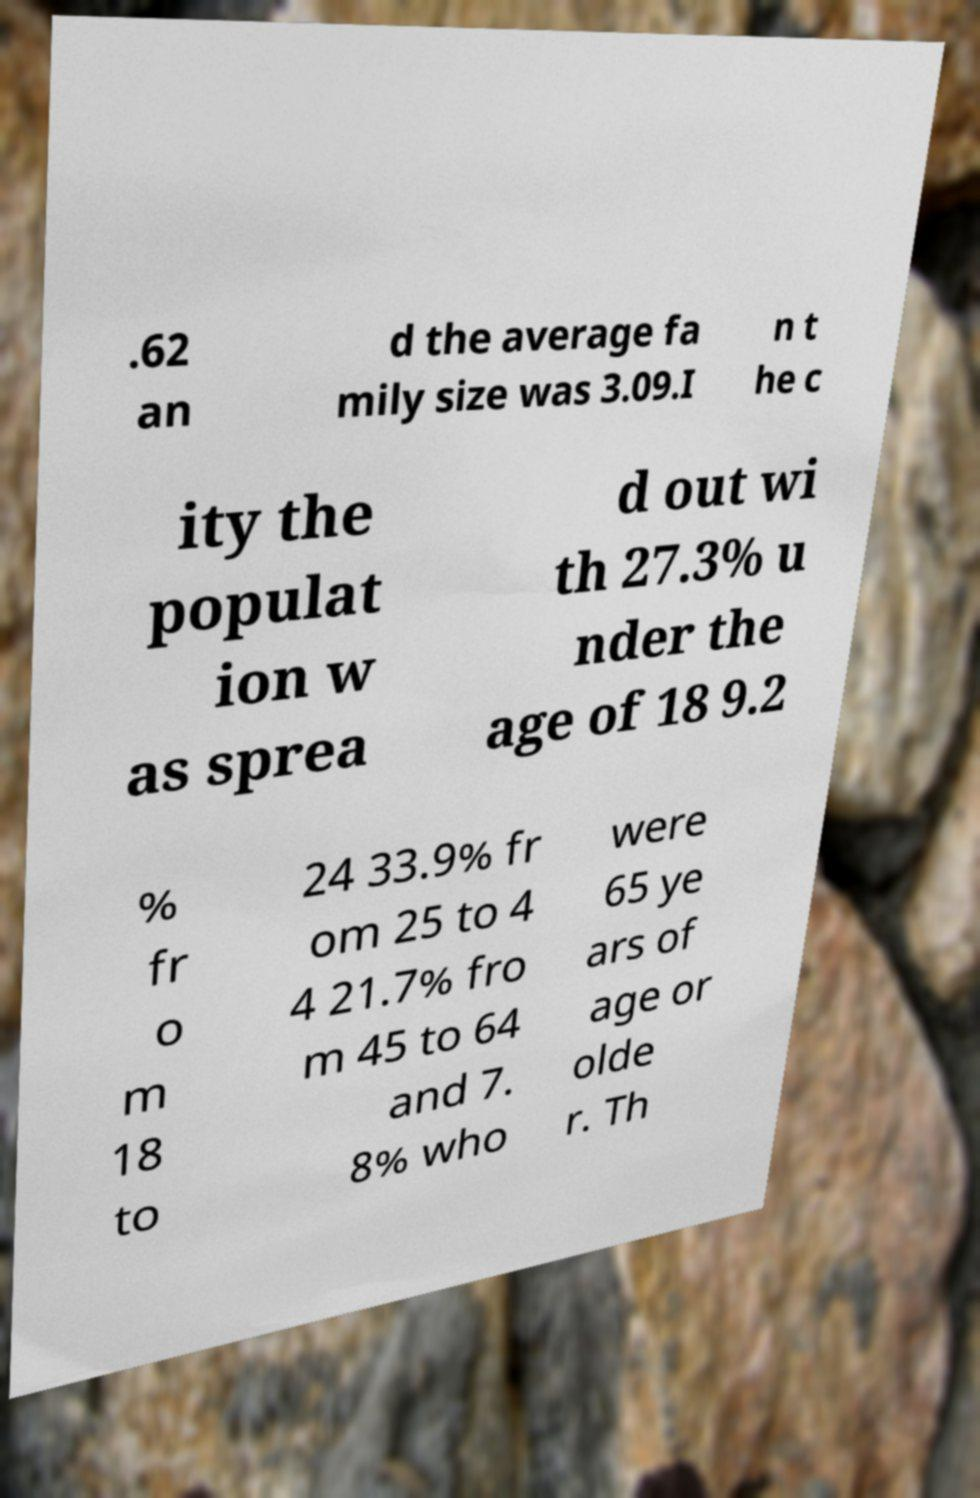Could you assist in decoding the text presented in this image and type it out clearly? .62 an d the average fa mily size was 3.09.I n t he c ity the populat ion w as sprea d out wi th 27.3% u nder the age of 18 9.2 % fr o m 18 to 24 33.9% fr om 25 to 4 4 21.7% fro m 45 to 64 and 7. 8% who were 65 ye ars of age or olde r. Th 